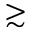Convert formula to latex. <formula><loc_0><loc_0><loc_500><loc_500>\gtrsim</formula> 